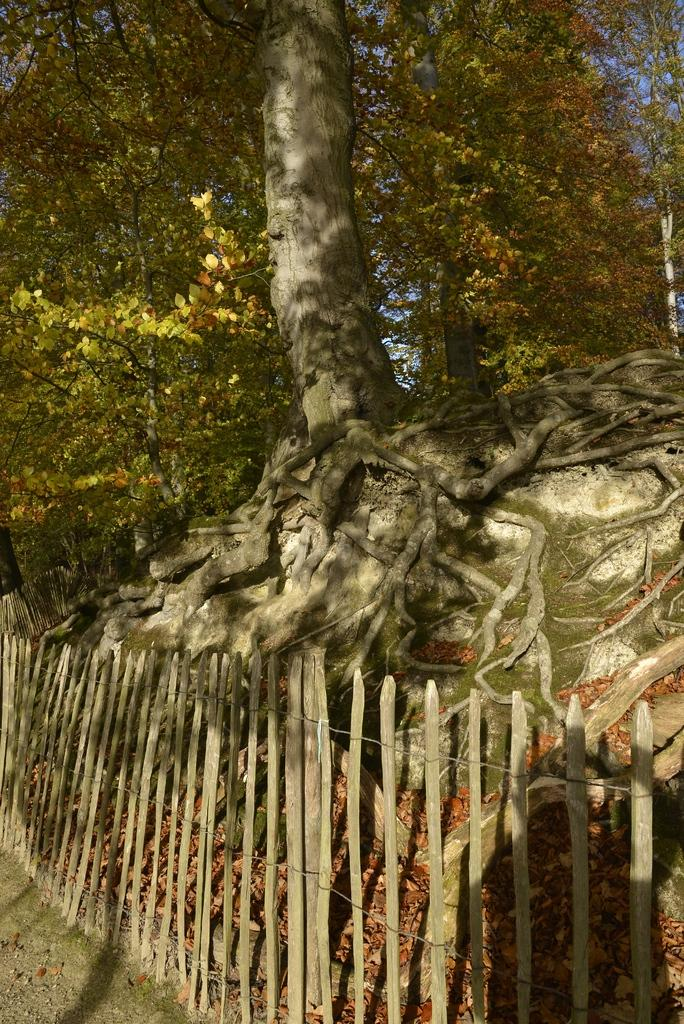What is the main feature of the image? There is a huge tree in the image. What is in front of the tree? There is a fencing with wooden sticks in front of the tree. What type of powder can be seen covering the leaves of the tree in the image? There is no powder visible on the tree in the image. How many houses are present near the tree in the image? There is no mention of houses in the image, only the tree and the fencing with wooden sticks. 